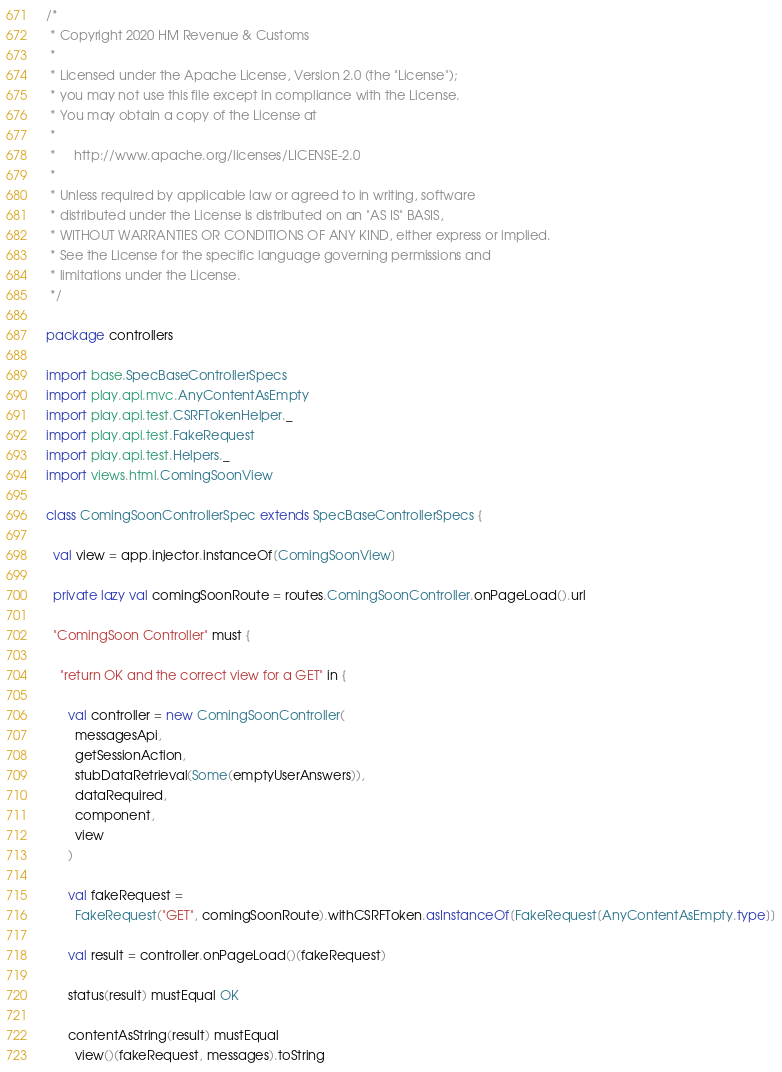Convert code to text. <code><loc_0><loc_0><loc_500><loc_500><_Scala_>/*
 * Copyright 2020 HM Revenue & Customs
 *
 * Licensed under the Apache License, Version 2.0 (the "License");
 * you may not use this file except in compliance with the License.
 * You may obtain a copy of the License at
 *
 *     http://www.apache.org/licenses/LICENSE-2.0
 *
 * Unless required by applicable law or agreed to in writing, software
 * distributed under the License is distributed on an "AS IS" BASIS,
 * WITHOUT WARRANTIES OR CONDITIONS OF ANY KIND, either express or implied.
 * See the License for the specific language governing permissions and
 * limitations under the License.
 */

package controllers

import base.SpecBaseControllerSpecs
import play.api.mvc.AnyContentAsEmpty
import play.api.test.CSRFTokenHelper._
import play.api.test.FakeRequest
import play.api.test.Helpers._
import views.html.ComingSoonView

class ComingSoonControllerSpec extends SpecBaseControllerSpecs {

  val view = app.injector.instanceOf[ComingSoonView]

  private lazy val comingSoonRoute = routes.ComingSoonController.onPageLoad().url

  "ComingSoon Controller" must {

    "return OK and the correct view for a GET" in {

      val controller = new ComingSoonController(
        messagesApi,
        getSessionAction,
        stubDataRetrieval(Some(emptyUserAnswers)),
        dataRequired,
        component,
        view
      )

      val fakeRequest =
        FakeRequest("GET", comingSoonRoute).withCSRFToken.asInstanceOf[FakeRequest[AnyContentAsEmpty.type]]

      val result = controller.onPageLoad()(fakeRequest)

      status(result) mustEqual OK

      contentAsString(result) mustEqual
        view()(fakeRequest, messages).toString</code> 